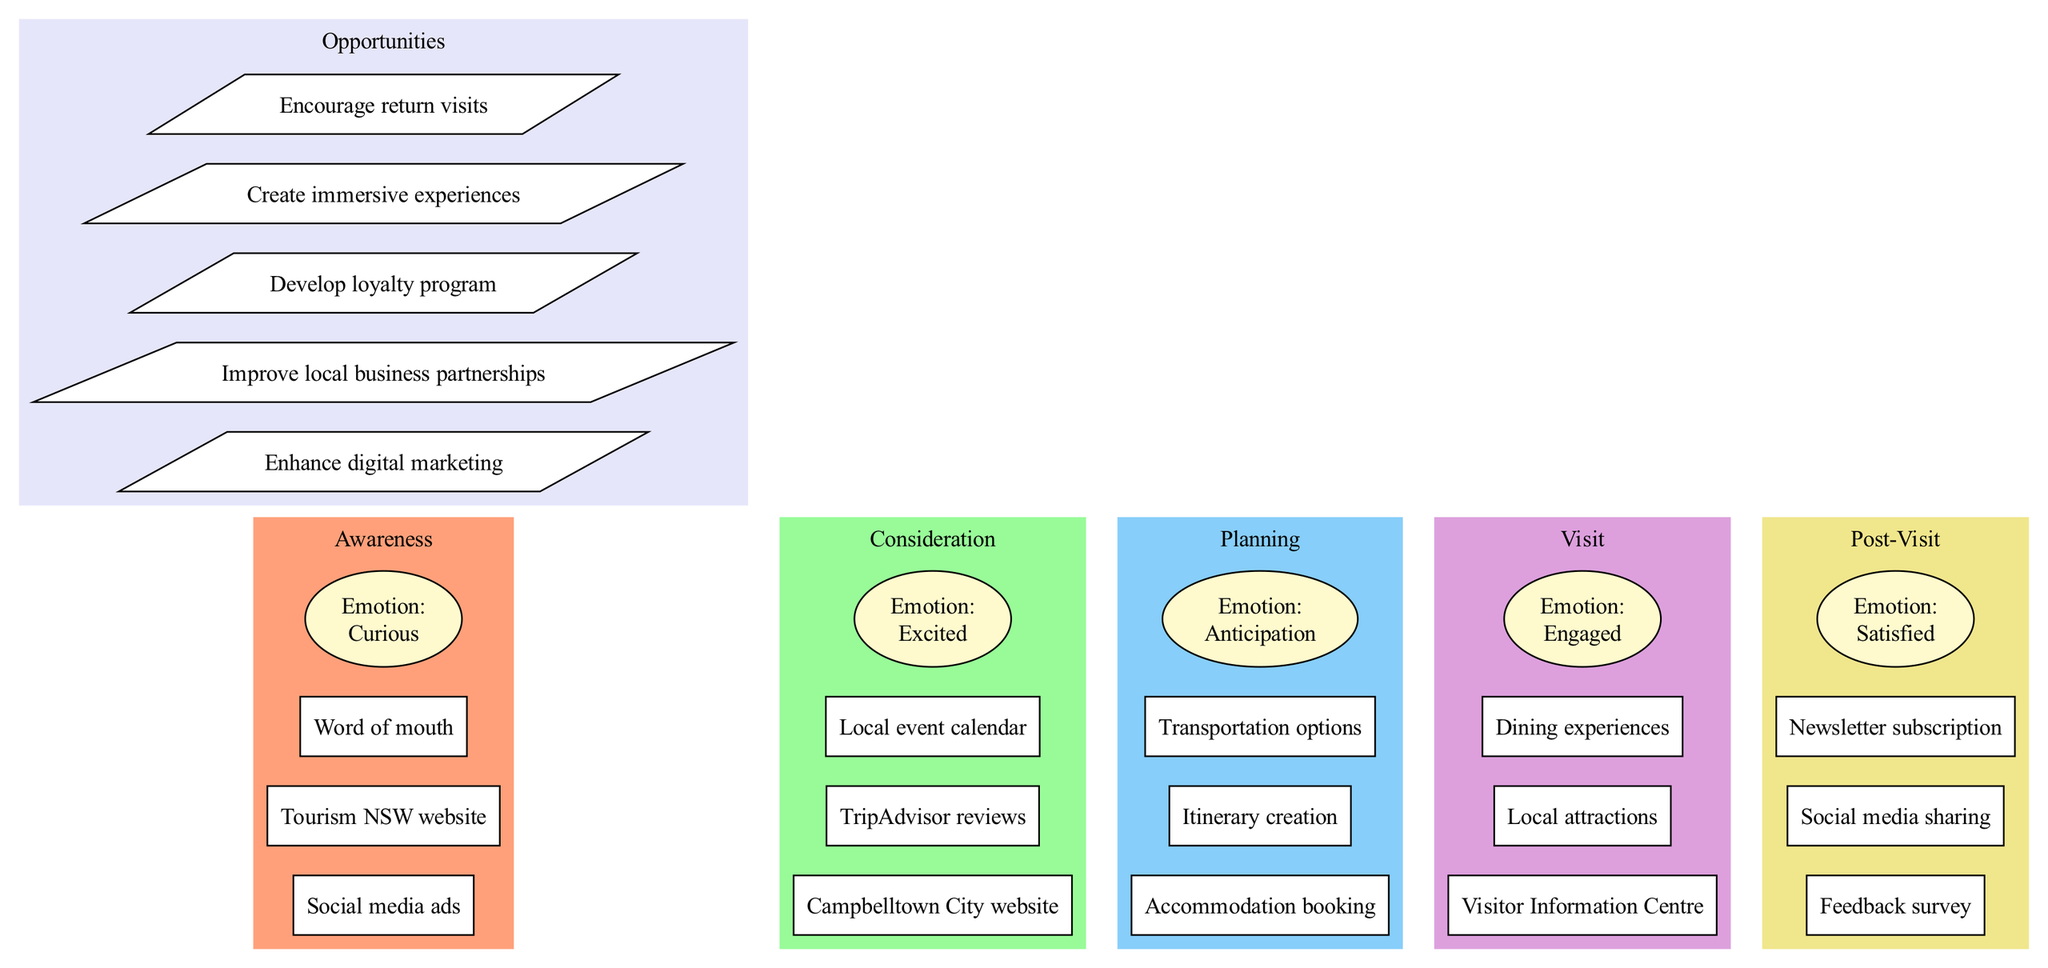What are the three touchpoints in the Awareness stage? The diagram lists three touchpoints under the Awareness stage: Social media ads, Tourism NSW website, and Word of mouth.
Answer: Social media ads, Tourism NSW website, Word of mouth What is the emotion associated with the Visit stage? By checking the emotions listed for each stage in the diagram, the emotion defined for the Visit stage is Engaged.
Answer: Engaged How many total stages are depicted in the diagram? The diagram specifies five distinct stages that visitors go through, which are Awareness, Consideration, Planning, Visit, and Post-Visit.
Answer: Five Which opportunity is listed last in the Opportunities section? Referring to the Opportunities section in the diagram, the last opportunity mentioned is Encourage return visits.
Answer: Encourage return visits What is the emotion the visitors feel during the Post-Visit stage? According to the emotions displayed in the diagram, the emotion associated with the Post-Visit stage is Satisfied.
Answer: Satisfied Identify one touchpoint from the Consideration stage. In the Consideration stage of the diagram, one of the touchpoints listed is Campbelltown City website.
Answer: Campbelltown City website What is the second touchpoint in the Planning stage? The Planning stage includes three touchpoints, and the second one listed is Itinerary creation.
Answer: Itinerary creation Which stage comes right after Planning? The flow of the diagram indicates that the stage that follows Planning is Visit.
Answer: Visit How many opportunities are presented in the Opportunities section? The diagram outlines a total of five opportunities that can be explored to enhance visitor engagement and experiences.
Answer: Five 